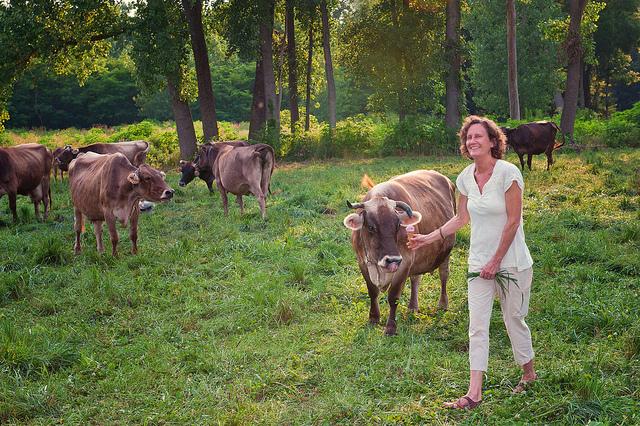What color pants is the woman wearing?
Be succinct. White. What type of animals are there?
Short answer required. Cows. What type of animals are in the picture?
Give a very brief answer. Cows. How many people are in this picture?
Write a very short answer. 1. Are these animals domesticated?
Keep it brief. Yes. 